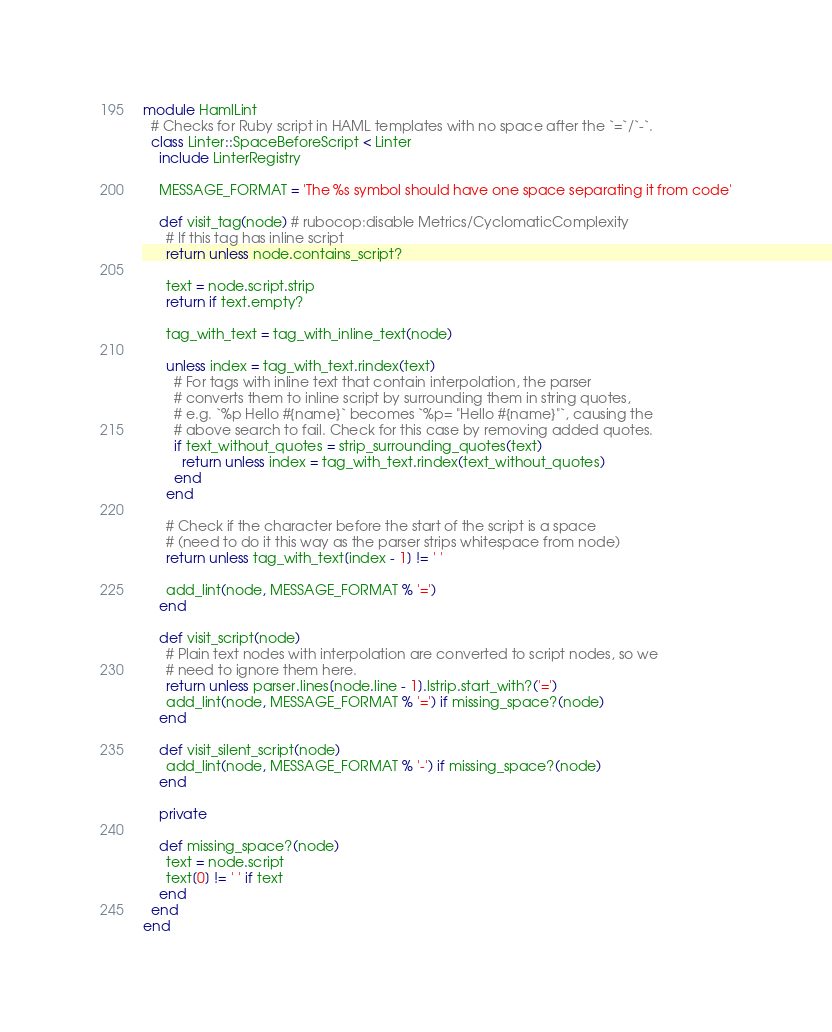<code> <loc_0><loc_0><loc_500><loc_500><_Ruby_>module HamlLint
  # Checks for Ruby script in HAML templates with no space after the `=`/`-`.
  class Linter::SpaceBeforeScript < Linter
    include LinterRegistry

    MESSAGE_FORMAT = 'The %s symbol should have one space separating it from code'

    def visit_tag(node) # rubocop:disable Metrics/CyclomaticComplexity
      # If this tag has inline script
      return unless node.contains_script?

      text = node.script.strip
      return if text.empty?

      tag_with_text = tag_with_inline_text(node)

      unless index = tag_with_text.rindex(text)
        # For tags with inline text that contain interpolation, the parser
        # converts them to inline script by surrounding them in string quotes,
        # e.g. `%p Hello #{name}` becomes `%p= "Hello #{name}"`, causing the
        # above search to fail. Check for this case by removing added quotes.
        if text_without_quotes = strip_surrounding_quotes(text)
          return unless index = tag_with_text.rindex(text_without_quotes)
        end
      end

      # Check if the character before the start of the script is a space
      # (need to do it this way as the parser strips whitespace from node)
      return unless tag_with_text[index - 1] != ' '

      add_lint(node, MESSAGE_FORMAT % '=')
    end

    def visit_script(node)
      # Plain text nodes with interpolation are converted to script nodes, so we
      # need to ignore them here.
      return unless parser.lines[node.line - 1].lstrip.start_with?('=')
      add_lint(node, MESSAGE_FORMAT % '=') if missing_space?(node)
    end

    def visit_silent_script(node)
      add_lint(node, MESSAGE_FORMAT % '-') if missing_space?(node)
    end

    private

    def missing_space?(node)
      text = node.script
      text[0] != ' ' if text
    end
  end
end
</code> 